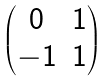Convert formula to latex. <formula><loc_0><loc_0><loc_500><loc_500>\begin{pmatrix} 0 & 1 \\ - 1 & 1 \end{pmatrix}</formula> 